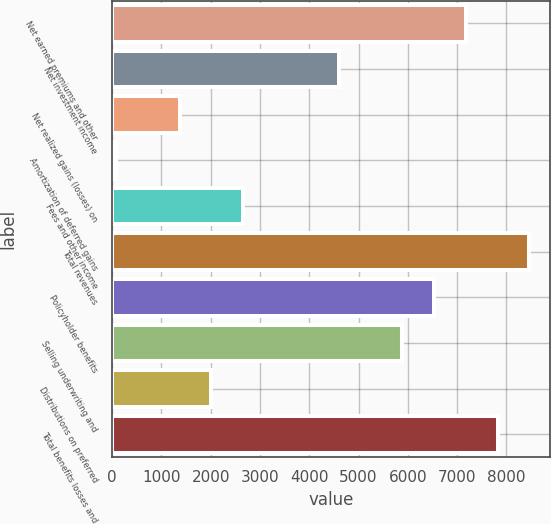Convert chart. <chart><loc_0><loc_0><loc_500><loc_500><bar_chart><fcel>Net earned premiums and other<fcel>Net investment income<fcel>Net realized gains (losses) on<fcel>Amortization of deferred gains<fcel>Fees and other income<fcel>Total revenues<fcel>Policyholder benefits<fcel>Selling underwriting and<fcel>Distributions on preferred<fcel>Total benefits losses and<nl><fcel>7177.2<fcel>4596.4<fcel>1370.4<fcel>80<fcel>2660.8<fcel>8467.6<fcel>6532<fcel>5886.8<fcel>2015.6<fcel>7822.4<nl></chart> 